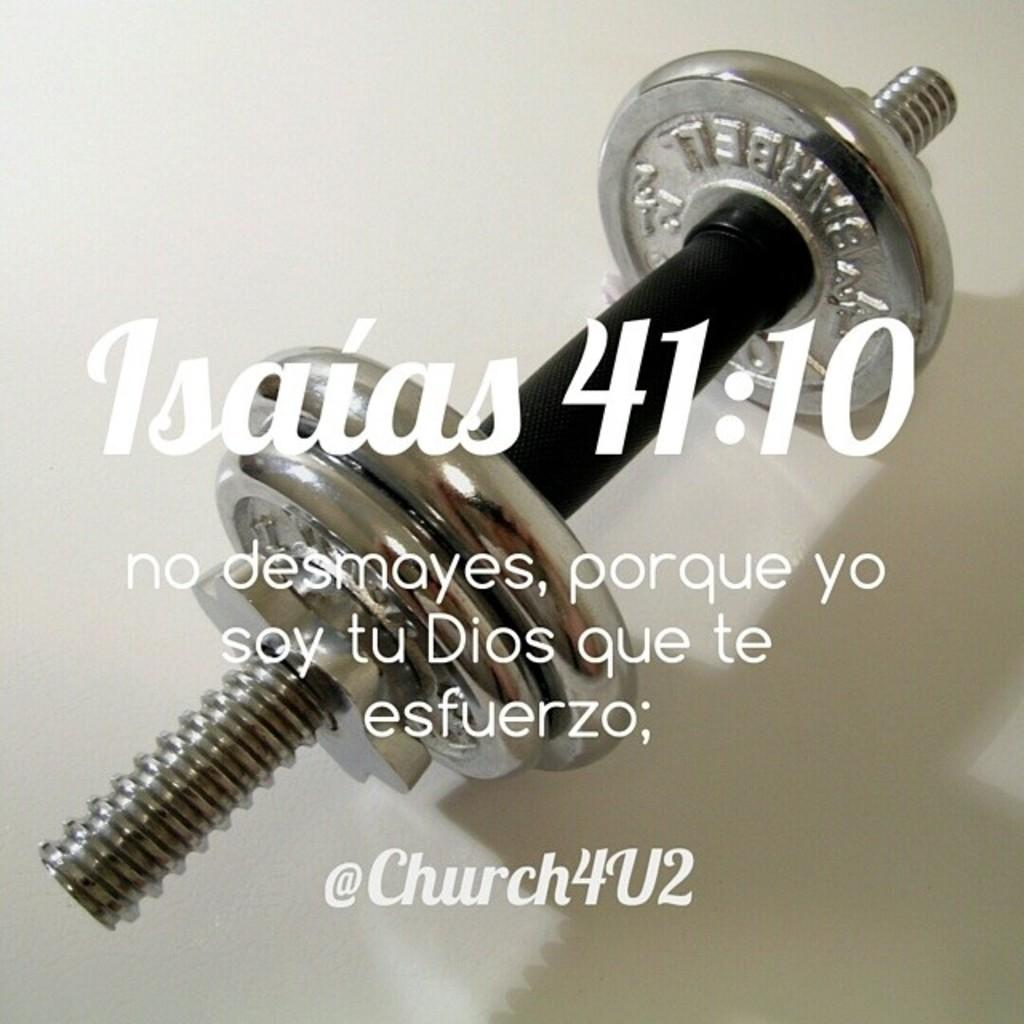What is the primary color of the surface in the image? The primary color of the surface in the image is white. What can be found on the white surface? There is an object in the image. Are there any textual elements in the image? Yes, there are words in the image. How many balloons are floating in the background of the image? There are no balloons present in the image. What is the plot of the story being told in the image? The image does not depict a story or plot; it contains a white surface with an object and words. 